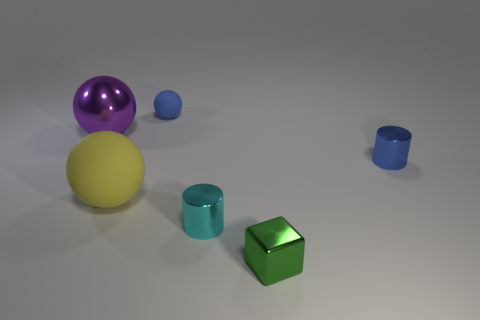What number of shiny blocks are the same color as the small sphere?
Offer a very short reply. 0. There is a metal object that is behind the small metal cylinder behind the tiny cyan object; what shape is it?
Ensure brevity in your answer.  Sphere. Is the number of tiny red shiny cubes the same as the number of green blocks?
Provide a succinct answer. No. What number of other things have the same material as the green thing?
Provide a short and direct response. 3. What is the material of the big ball that is left of the big yellow object?
Provide a succinct answer. Metal. What shape is the blue object left of the small blue thing in front of the large object left of the yellow object?
Provide a short and direct response. Sphere. Does the small cylinder left of the tiny metal block have the same color as the cylinder behind the yellow ball?
Your response must be concise. No. Is the number of tiny green things that are on the right side of the large purple metal object less than the number of tiny blue rubber spheres that are to the right of the small blue matte ball?
Offer a terse response. No. Are there any other things that have the same shape as the green shiny thing?
Your answer should be compact. No. The tiny rubber thing that is the same shape as the large rubber thing is what color?
Ensure brevity in your answer.  Blue. 